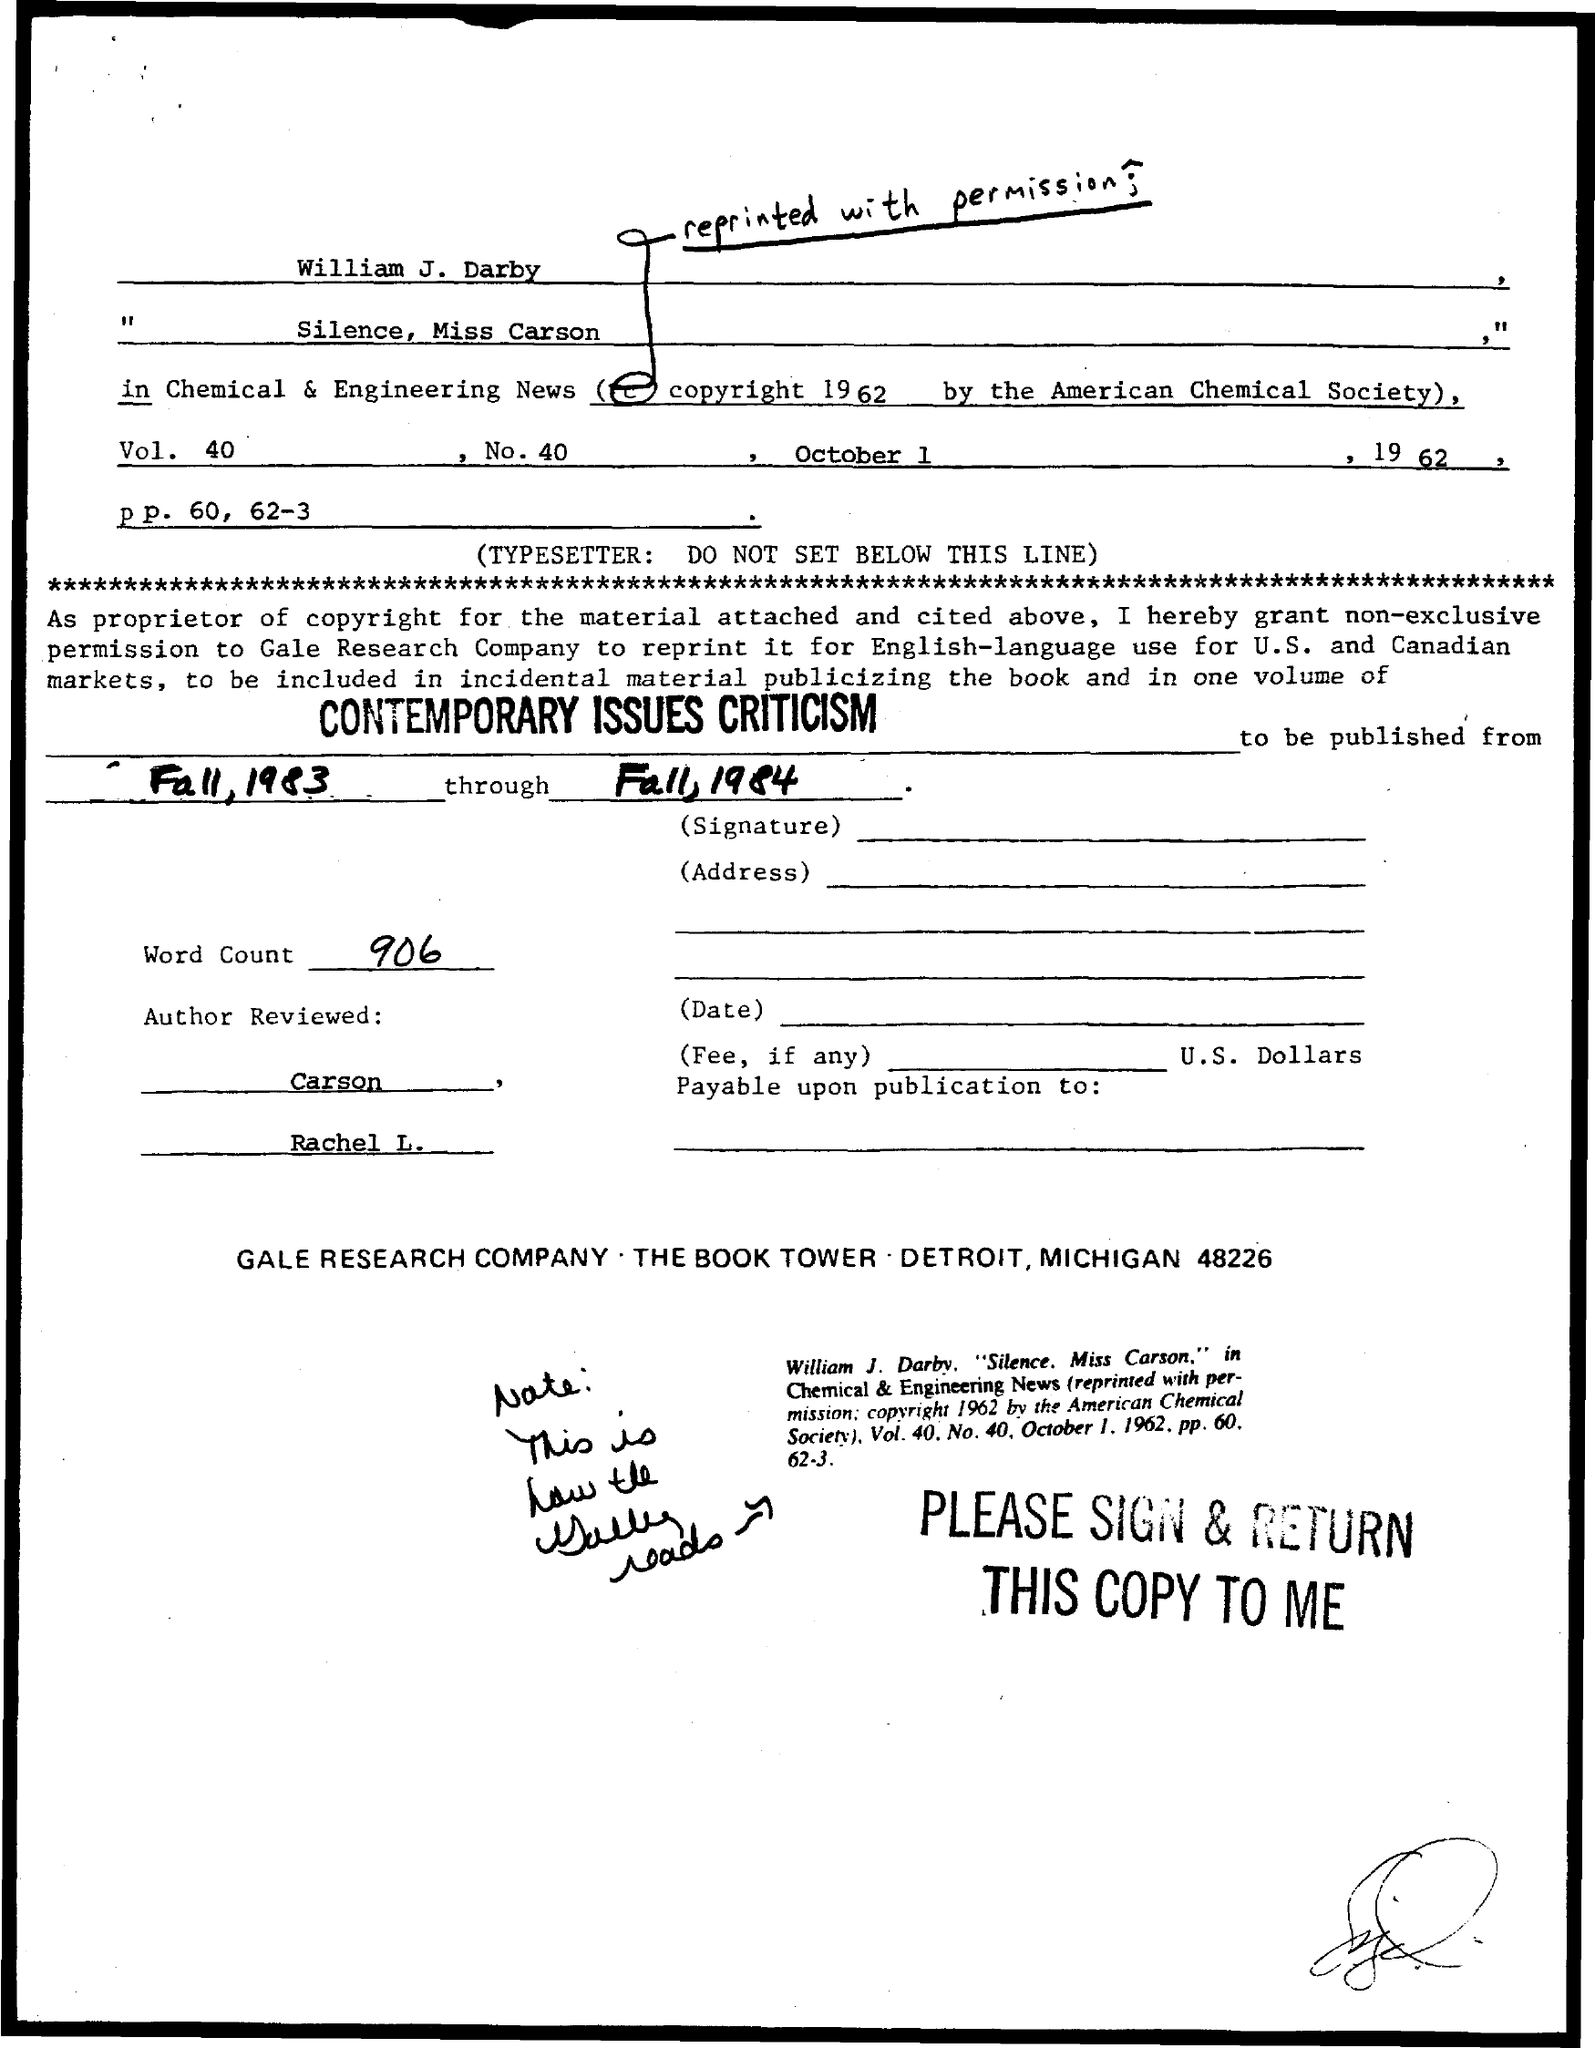Highlight a few significant elements in this photo. The word count mentioned is 906... The volume number mentioned is 40. The date mentioned is October 1, 1962. The number mentioned is 40... 